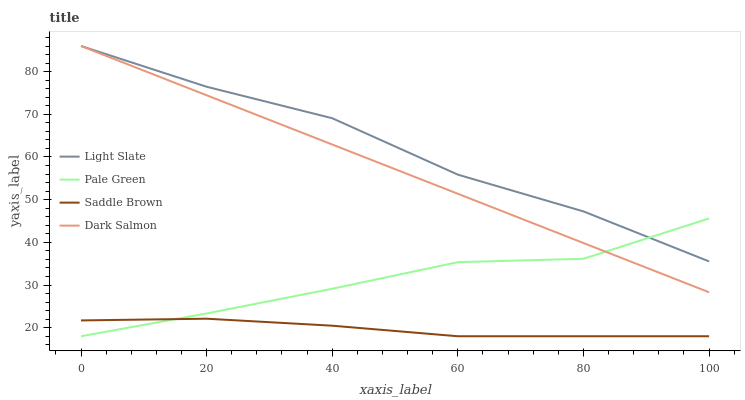Does Saddle Brown have the minimum area under the curve?
Answer yes or no. Yes. Does Light Slate have the maximum area under the curve?
Answer yes or no. Yes. Does Pale Green have the minimum area under the curve?
Answer yes or no. No. Does Pale Green have the maximum area under the curve?
Answer yes or no. No. Is Dark Salmon the smoothest?
Answer yes or no. Yes. Is Light Slate the roughest?
Answer yes or no. Yes. Is Pale Green the smoothest?
Answer yes or no. No. Is Pale Green the roughest?
Answer yes or no. No. Does Pale Green have the lowest value?
Answer yes or no. Yes. Does Dark Salmon have the lowest value?
Answer yes or no. No. Does Dark Salmon have the highest value?
Answer yes or no. Yes. Does Pale Green have the highest value?
Answer yes or no. No. Is Saddle Brown less than Light Slate?
Answer yes or no. Yes. Is Light Slate greater than Saddle Brown?
Answer yes or no. Yes. Does Dark Salmon intersect Pale Green?
Answer yes or no. Yes. Is Dark Salmon less than Pale Green?
Answer yes or no. No. Is Dark Salmon greater than Pale Green?
Answer yes or no. No. Does Saddle Brown intersect Light Slate?
Answer yes or no. No. 